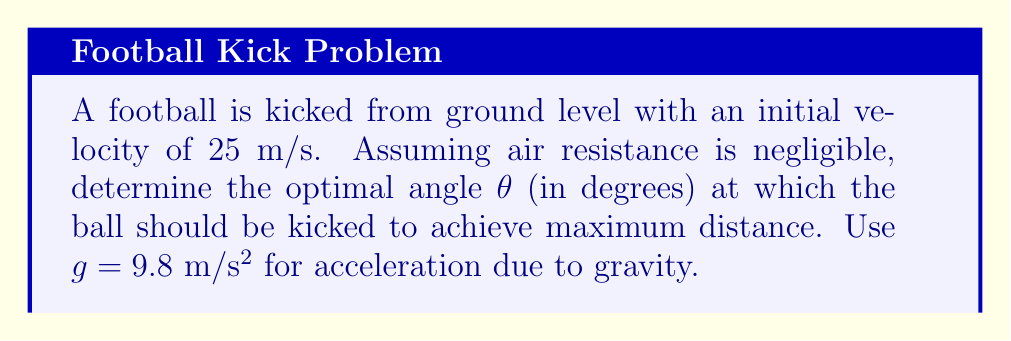Can you answer this question? To solve this problem, we'll use concepts from projectile motion and calculus:

1) The range (R) of a projectile launched from ground level is given by:

   $$R = \frac{v_0^2 \sin(2\theta)}{g}$$

   where $v_0$ is the initial velocity, $\theta$ is the launch angle, and $g$ is the acceleration due to gravity.

2) To find the maximum range, we need to find the angle $\theta$ that maximizes this function. We can do this by taking the derivative of R with respect to $\theta$ and setting it to zero:

   $$\frac{dR}{d\theta} = \frac{v_0^2}{g} \cdot 2\cos(2\theta) = 0$$

3) Solving this equation:

   $$2\cos(2\theta) = 0$$
   $$\cos(2\theta) = 0$$

4) The cosine function is zero when its argument is $\frac{\pi}{2}$ or $\frac{3\pi}{2}$ radians. Since we're dealing with a launch angle, we're interested in the solution in the first quadrant:

   $$2\theta = \frac{\pi}{2}$$
   $$\theta = \frac{\pi}{4} = 45°$$

5) To confirm this is a maximum (not a minimum), we could take the second derivative and show it's negative at this point, but it's well known that 45° gives the maximum range for projectile motion from ground level.

Therefore, the optimal angle to maximize the distance of the football kick is 45°.
Answer: 45° 